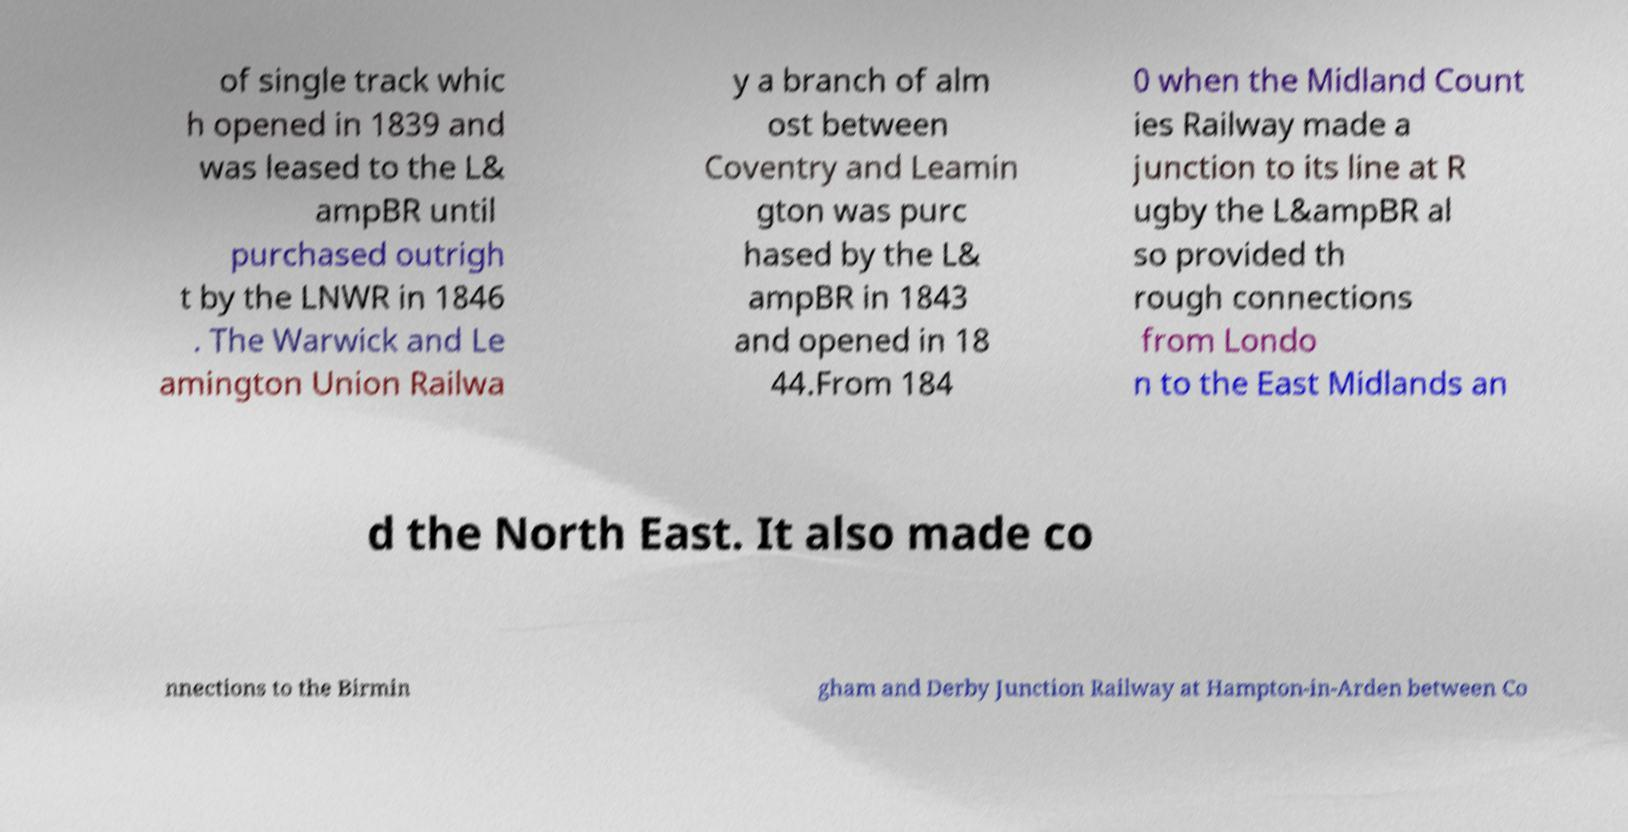Could you extract and type out the text from this image? of single track whic h opened in 1839 and was leased to the L& ampBR until purchased outrigh t by the LNWR in 1846 . The Warwick and Le amington Union Railwa y a branch of alm ost between Coventry and Leamin gton was purc hased by the L& ampBR in 1843 and opened in 18 44.From 184 0 when the Midland Count ies Railway made a junction to its line at R ugby the L&ampBR al so provided th rough connections from Londo n to the East Midlands an d the North East. It also made co nnections to the Birmin gham and Derby Junction Railway at Hampton-in-Arden between Co 